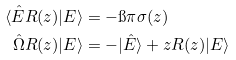<formula> <loc_0><loc_0><loc_500><loc_500>\langle \hat { E } R ( z ) | E \rangle & = - \i \pi \sigma ( z ) \\ \hat { \Omega } R ( z ) | E \rangle & = - | \hat { E } \rangle + z R ( z ) | E \rangle</formula> 